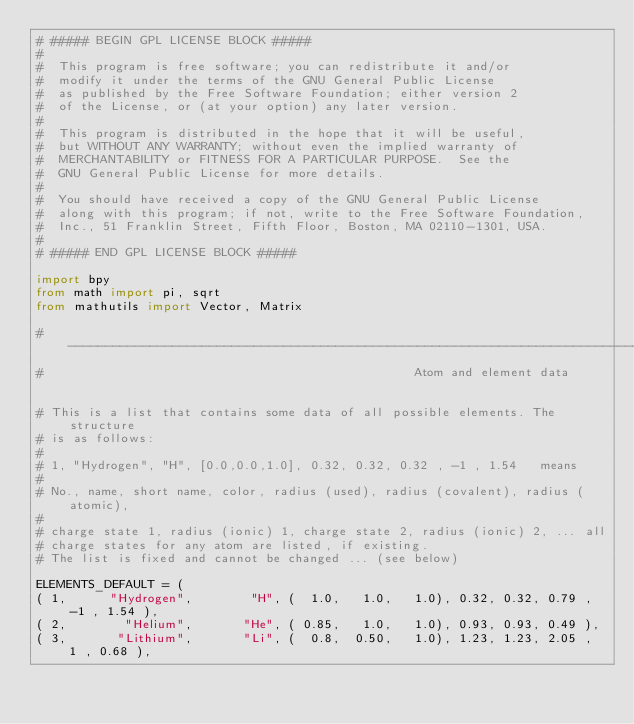<code> <loc_0><loc_0><loc_500><loc_500><_Python_># ##### BEGIN GPL LICENSE BLOCK #####
#
#  This program is free software; you can redistribute it and/or
#  modify it under the terms of the GNU General Public License
#  as published by the Free Software Foundation; either version 2
#  of the License, or (at your option) any later version.
#
#  This program is distributed in the hope that it will be useful,
#  but WITHOUT ANY WARRANTY; without even the implied warranty of
#  MERCHANTABILITY or FITNESS FOR A PARTICULAR PURPOSE.  See the
#  GNU General Public License for more details.
#
#  You should have received a copy of the GNU General Public License
#  along with this program; if not, write to the Free Software Foundation,
#  Inc., 51 Franklin Street, Fifth Floor, Boston, MA 02110-1301, USA.
#
# ##### END GPL LICENSE BLOCK #####

import bpy
from math import pi, sqrt
from mathutils import Vector, Matrix

# -----------------------------------------------------------------------------
#                                                  Atom and element data


# This is a list that contains some data of all possible elements. The structure
# is as follows:
#
# 1, "Hydrogen", "H", [0.0,0.0,1.0], 0.32, 0.32, 0.32 , -1 , 1.54   means
#
# No., name, short name, color, radius (used), radius (covalent), radius (atomic),
#
# charge state 1, radius (ionic) 1, charge state 2, radius (ionic) 2, ... all
# charge states for any atom are listed, if existing.
# The list is fixed and cannot be changed ... (see below)

ELEMENTS_DEFAULT = (
( 1,      "Hydrogen",        "H", (  1.0,   1.0,   1.0), 0.32, 0.32, 0.79 , -1 , 1.54 ),
( 2,        "Helium",       "He", ( 0.85,   1.0,   1.0), 0.93, 0.93, 0.49 ),
( 3,       "Lithium",       "Li", (  0.8,  0.50,   1.0), 1.23, 1.23, 2.05 ,  1 , 0.68 ),</code> 